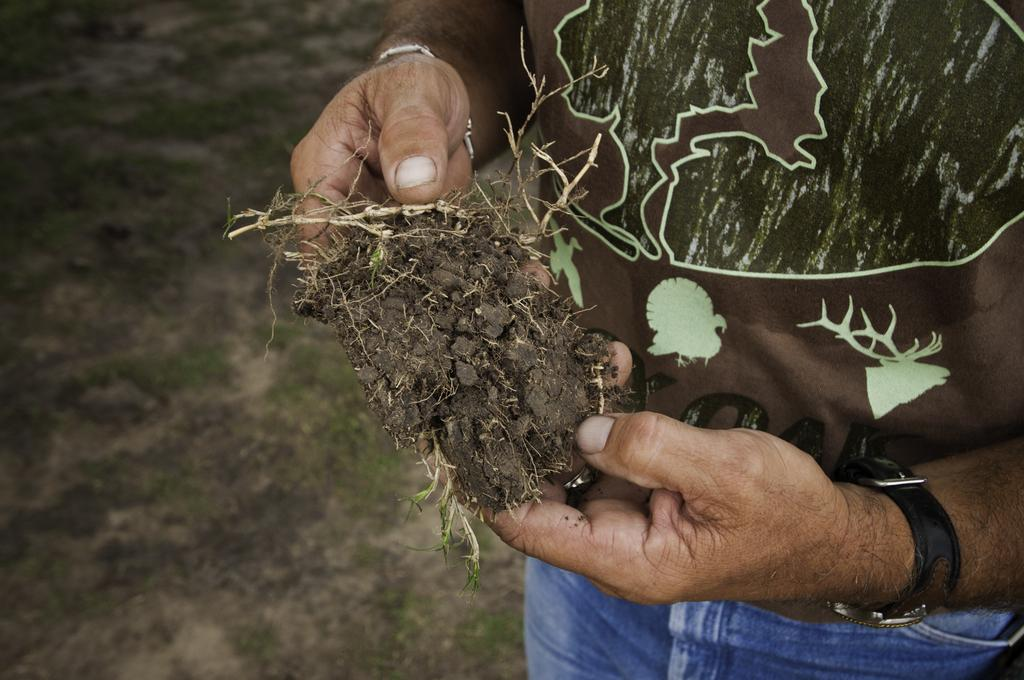Who is present in the image? There is a person in the image. What is the person holding in the image? The person is holding mud and a plant. What type of vegetation is visible on the ground in the image? The ground is covered with grass. What type of advice does the doctor give to the person's aunt at night in the image? There is no doctor, aunt, or nighttime setting present in the image. 